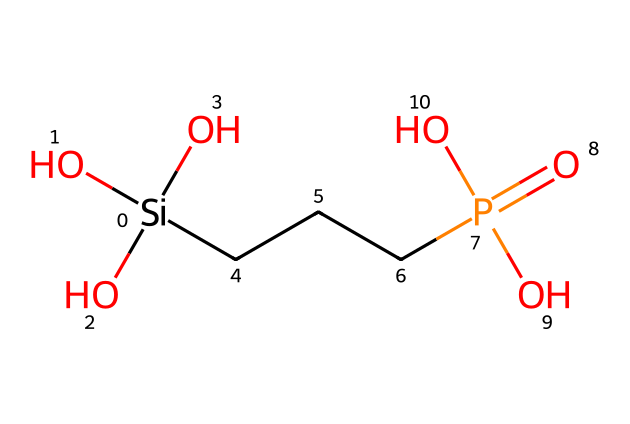How many silicon atoms are present in the structure? The structure shows one silicon atom, indicated by the [Si] label in the SMILES representation.
Answer: one What functional groups are present in this compound? The compound contains hydroxyl groups (–OH) indicated by the "O" components following the silicon. Additionally, it has a phosphate group (P(=O)(O)O) represented by the "P" and surrounding oxygens.
Answer: hydroxyl and phosphate What is the oxidation state of the silicon in this compound? Silicon typically has an oxidation state of +4 when it forms four bonds. In this structure, it is bonded to three hydroxyl groups and a carbon chain which implies a +4 state.
Answer: +4 What type of reaction would likely occur involving this compound? Given its structure as a flame retardant, it is likely to undergo dehydration or thermolysis reactions, especially under high temperatures.
Answer: dehydration How does the presence of the phosphate group contribute to flame retardancy? Phosphate groups can enhance flame retardancy by promoting char formation and releasing non-flammable gases when thermally decomposed, helping to prevent ignition.
Answer: char formation What role does the carbon chain play in the structure? The carbon chain (CC) acts as a backbone, providing structure and stability while also helping to disperse the silicon and phosphorus components in the material, thus enhancing effectiveness as a flame retardant.
Answer: backbone structure 